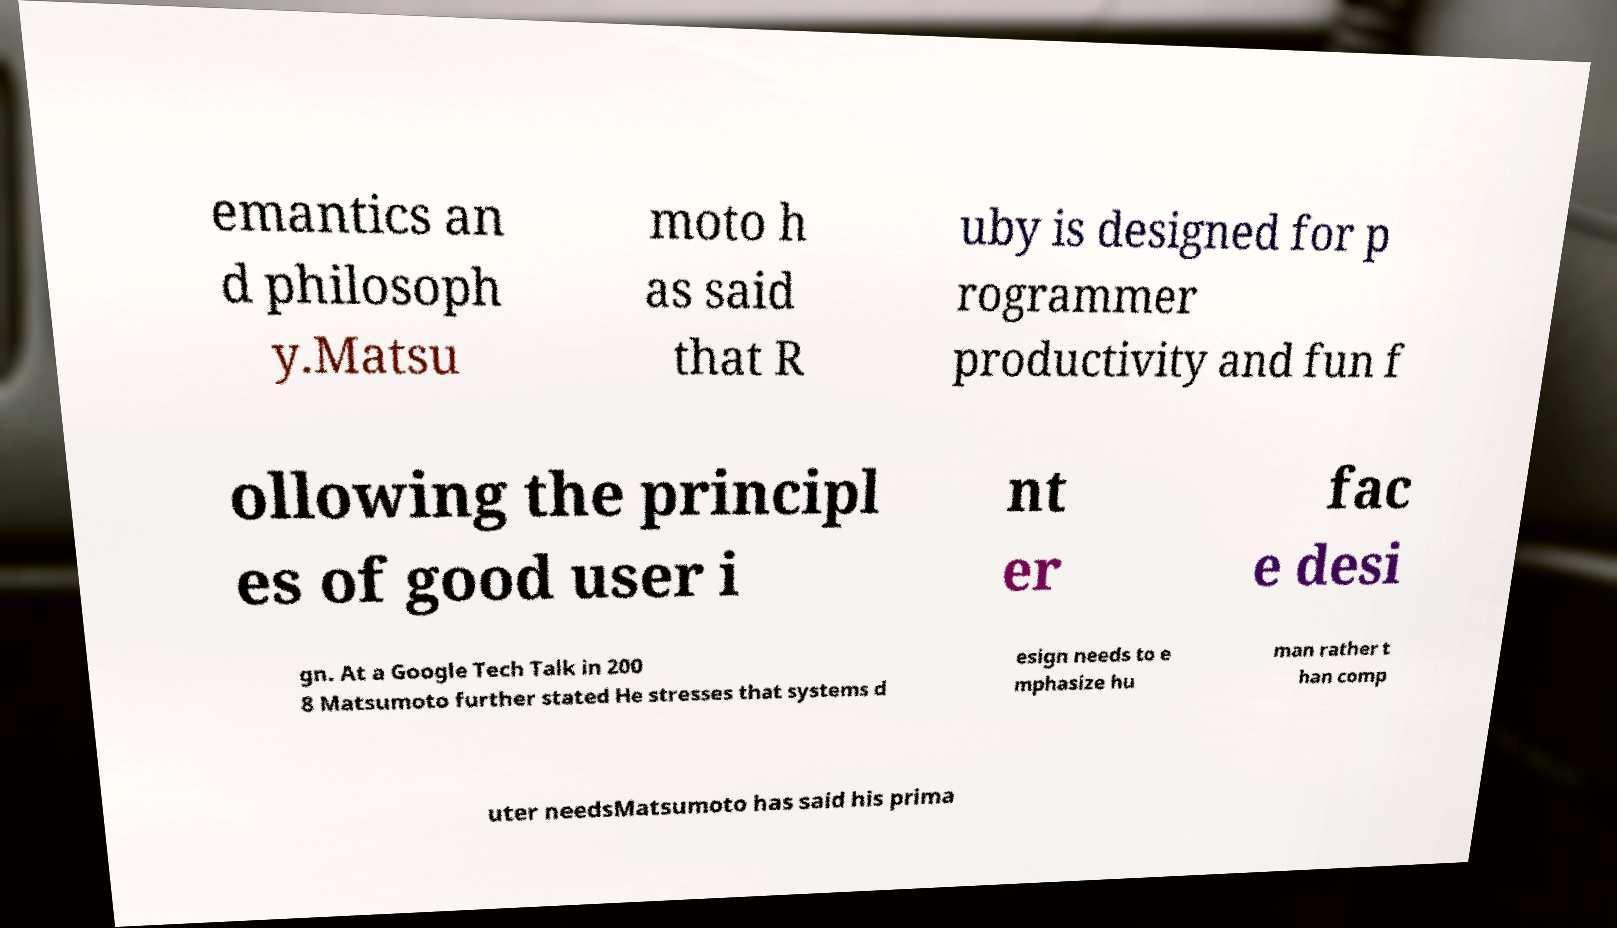Please identify and transcribe the text found in this image. emantics an d philosoph y.Matsu moto h as said that R uby is designed for p rogrammer productivity and fun f ollowing the principl es of good user i nt er fac e desi gn. At a Google Tech Talk in 200 8 Matsumoto further stated He stresses that systems d esign needs to e mphasize hu man rather t han comp uter needsMatsumoto has said his prima 